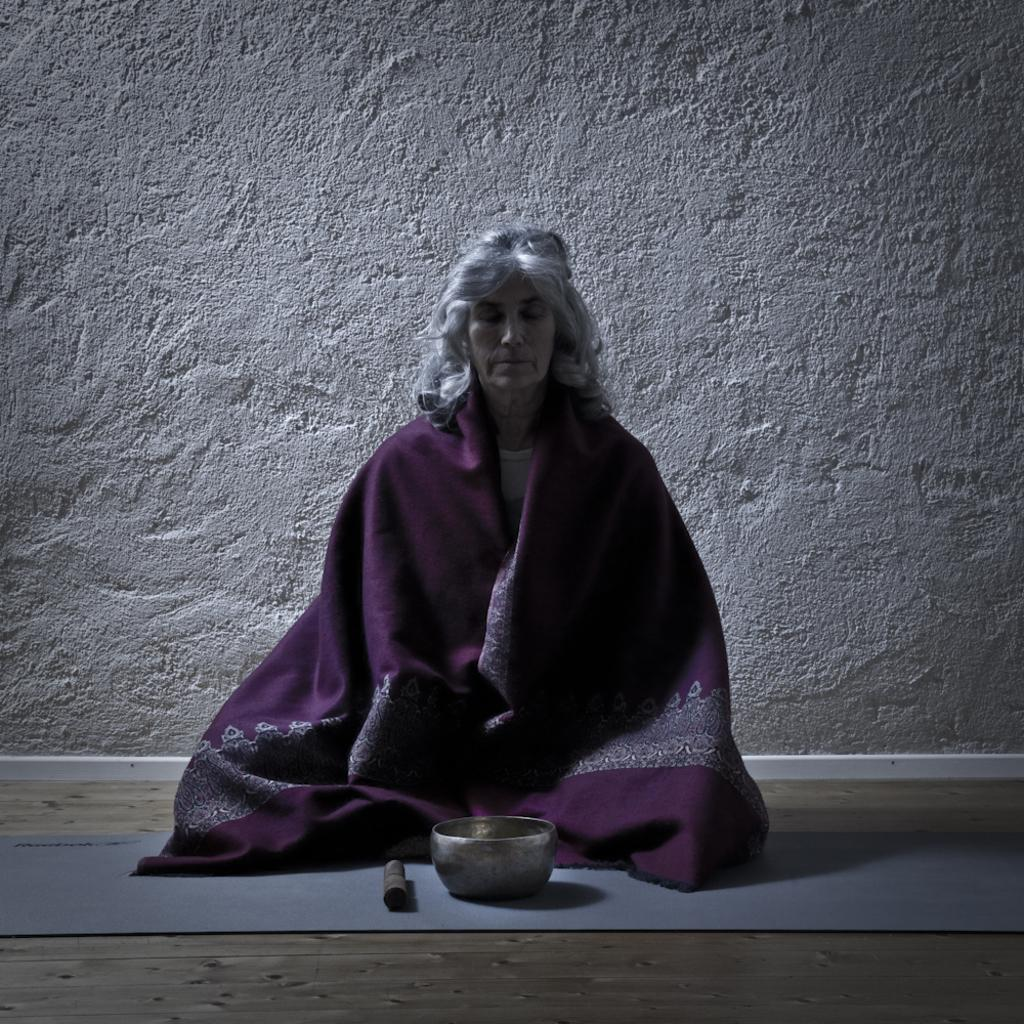What is the person in the image doing? There is a person sitting in the image. What is on the ground near the person? There is a bowl on the ground in the image. What can be seen in the background of the image? There is a wall visible in the image. What type of plantation can be seen in the image? There is no plantation present in the image; it only features a person sitting, a bowl on the ground, and a wall in the background. 